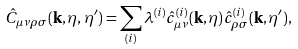<formula> <loc_0><loc_0><loc_500><loc_500>\hat { C } _ { \mu \nu \rho \sigma } ( { \mathbf k } , \eta , \eta ^ { \prime } ) = \sum _ { ( i ) } \lambda ^ { ( i ) } \hat { c } _ { \mu \nu } ^ { ( i ) } ( { \mathbf k } , \eta ) \hat { c } _ { \rho \sigma } ^ { ( i ) } ( { \mathbf k } , \eta ^ { \prime } ) ,</formula> 